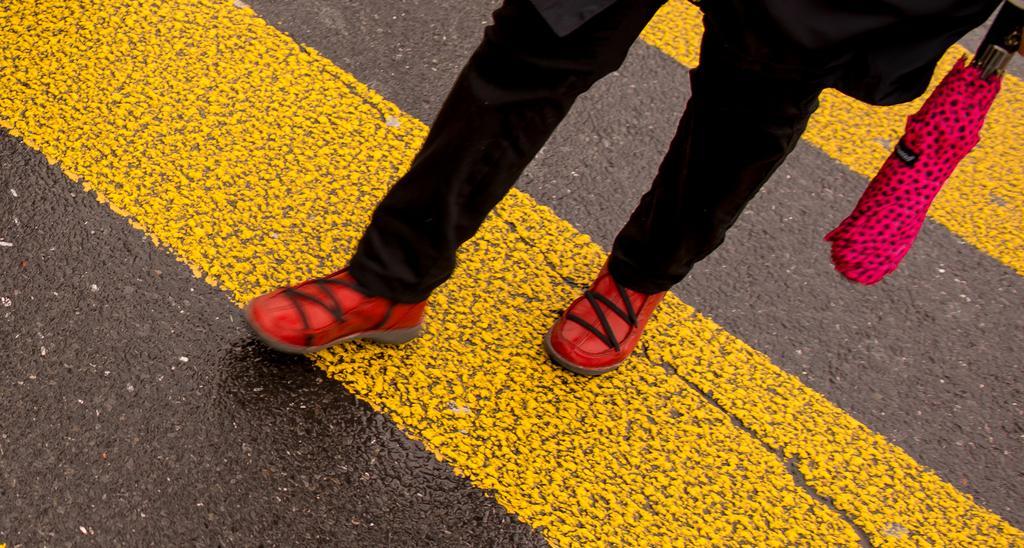Describe this image in one or two sentences. In the center of the image we can see the legs of a person on the road. On the right side of the image, we can see an umbrella. 